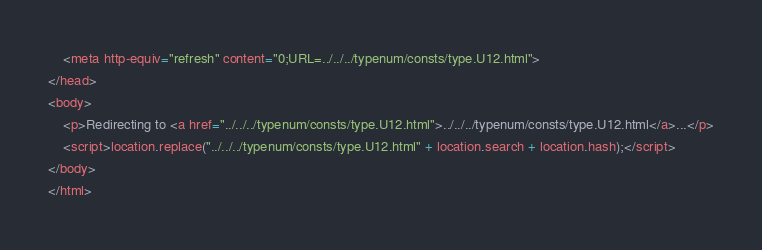Convert code to text. <code><loc_0><loc_0><loc_500><loc_500><_HTML_>    <meta http-equiv="refresh" content="0;URL=../../../typenum/consts/type.U12.html">
</head>
<body>
    <p>Redirecting to <a href="../../../typenum/consts/type.U12.html">../../../typenum/consts/type.U12.html</a>...</p>
    <script>location.replace("../../../typenum/consts/type.U12.html" + location.search + location.hash);</script>
</body>
</html></code> 